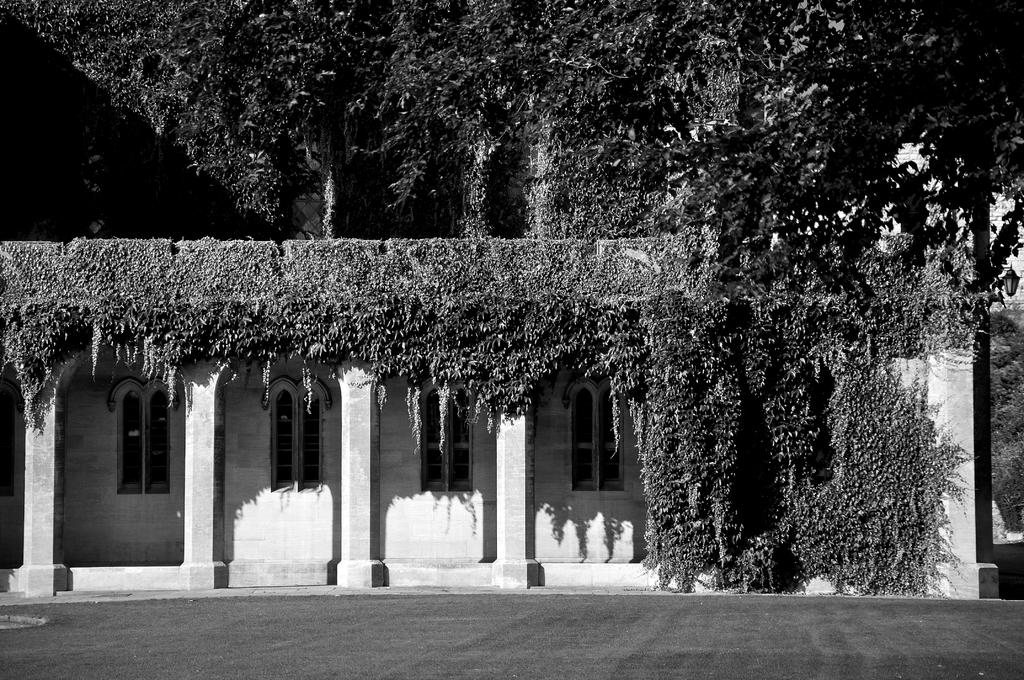What type of structures are present in the image? There are walls, windows, and pillars in the image. What type of vegetation can be seen in the image? There are plants and trees in the image. What is at the bottom of the image? There is grass at the bottom of the image. What type of behavior can be observed in the dinosaurs in the image? There are no dinosaurs present in the image. What advice might the dad give to the children in the image? There are no children or dad present in the image. 